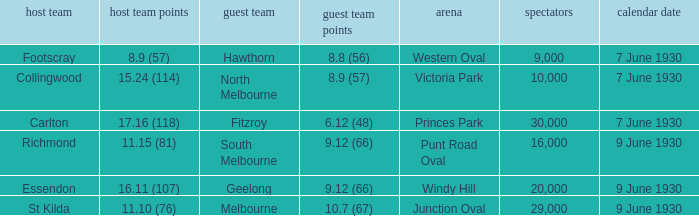What is the average crowd to watch Hawthorn as the away team? 9000.0. 